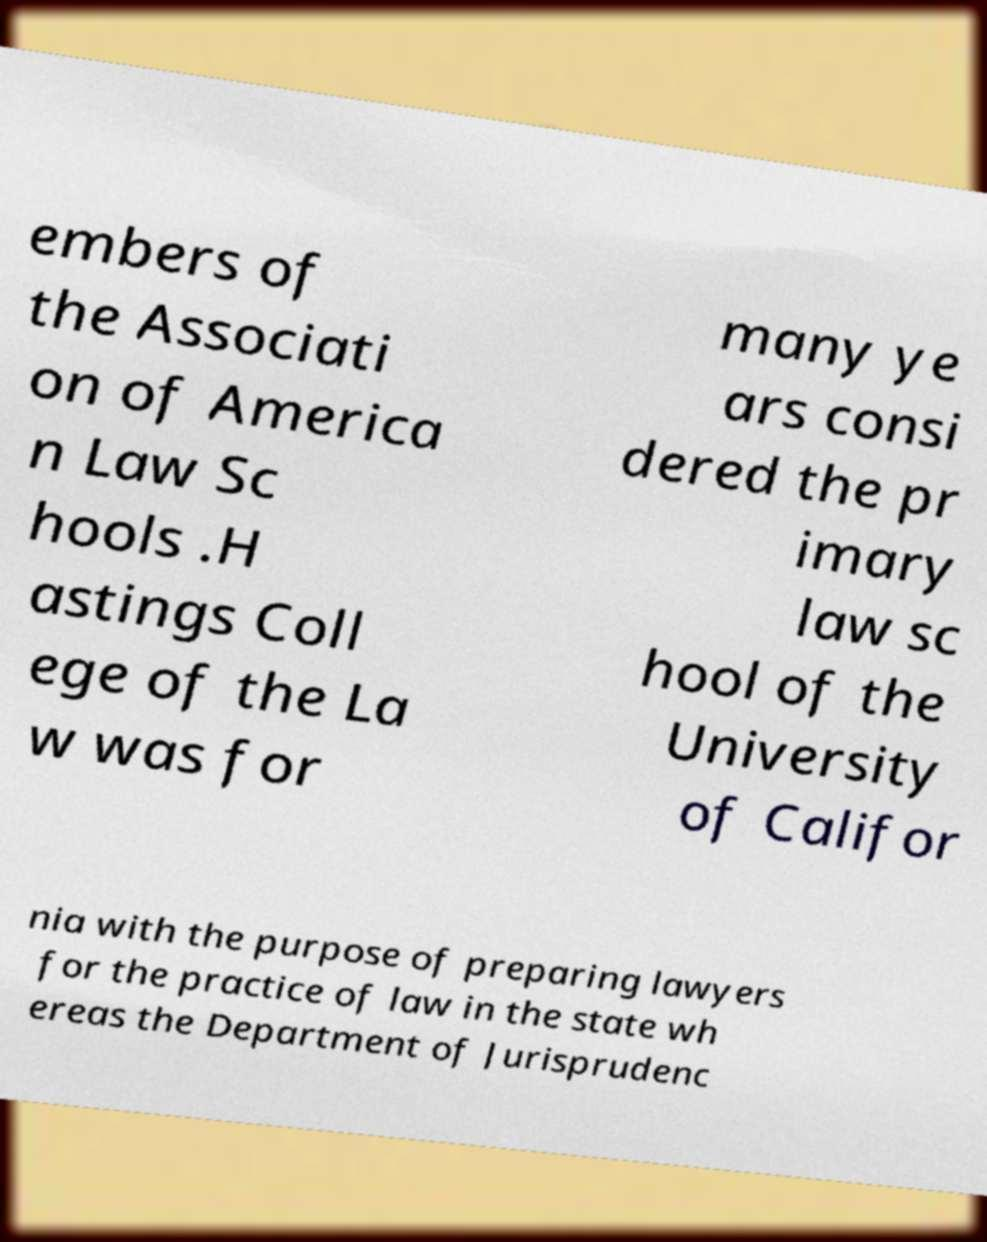I need the written content from this picture converted into text. Can you do that? embers of the Associati on of America n Law Sc hools .H astings Coll ege of the La w was for many ye ars consi dered the pr imary law sc hool of the University of Califor nia with the purpose of preparing lawyers for the practice of law in the state wh ereas the Department of Jurisprudenc 